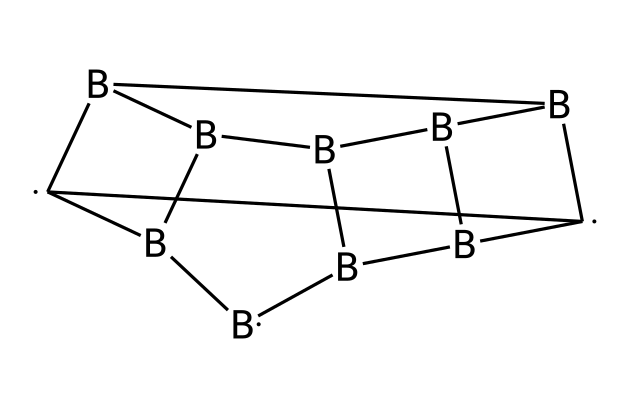What is the total number of boron atoms in this structure? The SMILES representation indicates the presence of six boron atoms, as denoted by the [B] symbols.
Answer: six How many carbon atoms are present in the chemical? The structure contains four carbon atoms, represented by the occurrences of [C] in the SMILES notation.
Answer: four Which element provides the unique properties of this compound? The boron atoms in this compound give it its unique properties related to its ability to form complex clusters and contribute to the material's performance in radiation shielding.
Answer: boron What is the connectivity type of this chemical? The chemical structure features a polyhedral and cluster arrangement, which is typical for carboranes, indicating that it has a three-dimensional connectivity pattern.
Answer: polyhedral How does the arrangement of atoms affect its radiation shielding properties? The unique geometric arrangement of boron and carbon atoms enhances the effectiveness of this material in attenuating radiation due to the high cross-section for neutron capture provided by the boron atoms.
Answer: enhances attenuation What is the molecular formula derived from the given SMILES? The SMILES can be translated to reveal that the molecular formula is C2B10, indicating two carbon atoms and ten boron atoms in total, consistent with the borane family.
Answer: C2B10 Which structural feature allows this chemical to be effective in space applications? The cluster structure of carboranes allows for exceptional stability and lightweight, crucial characteristics for materials used in radiation shielding for spacecraft.
Answer: cluster structure 